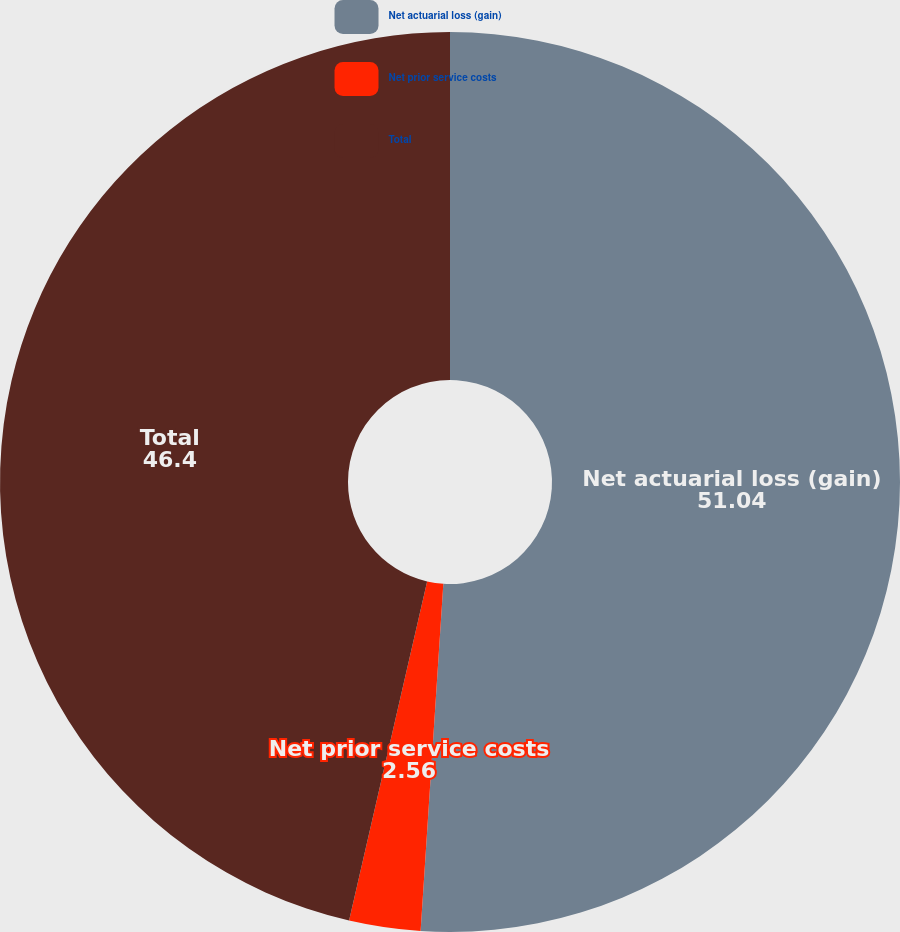Convert chart to OTSL. <chart><loc_0><loc_0><loc_500><loc_500><pie_chart><fcel>Net actuarial loss (gain)<fcel>Net prior service costs<fcel>Total<nl><fcel>51.04%<fcel>2.56%<fcel>46.4%<nl></chart> 